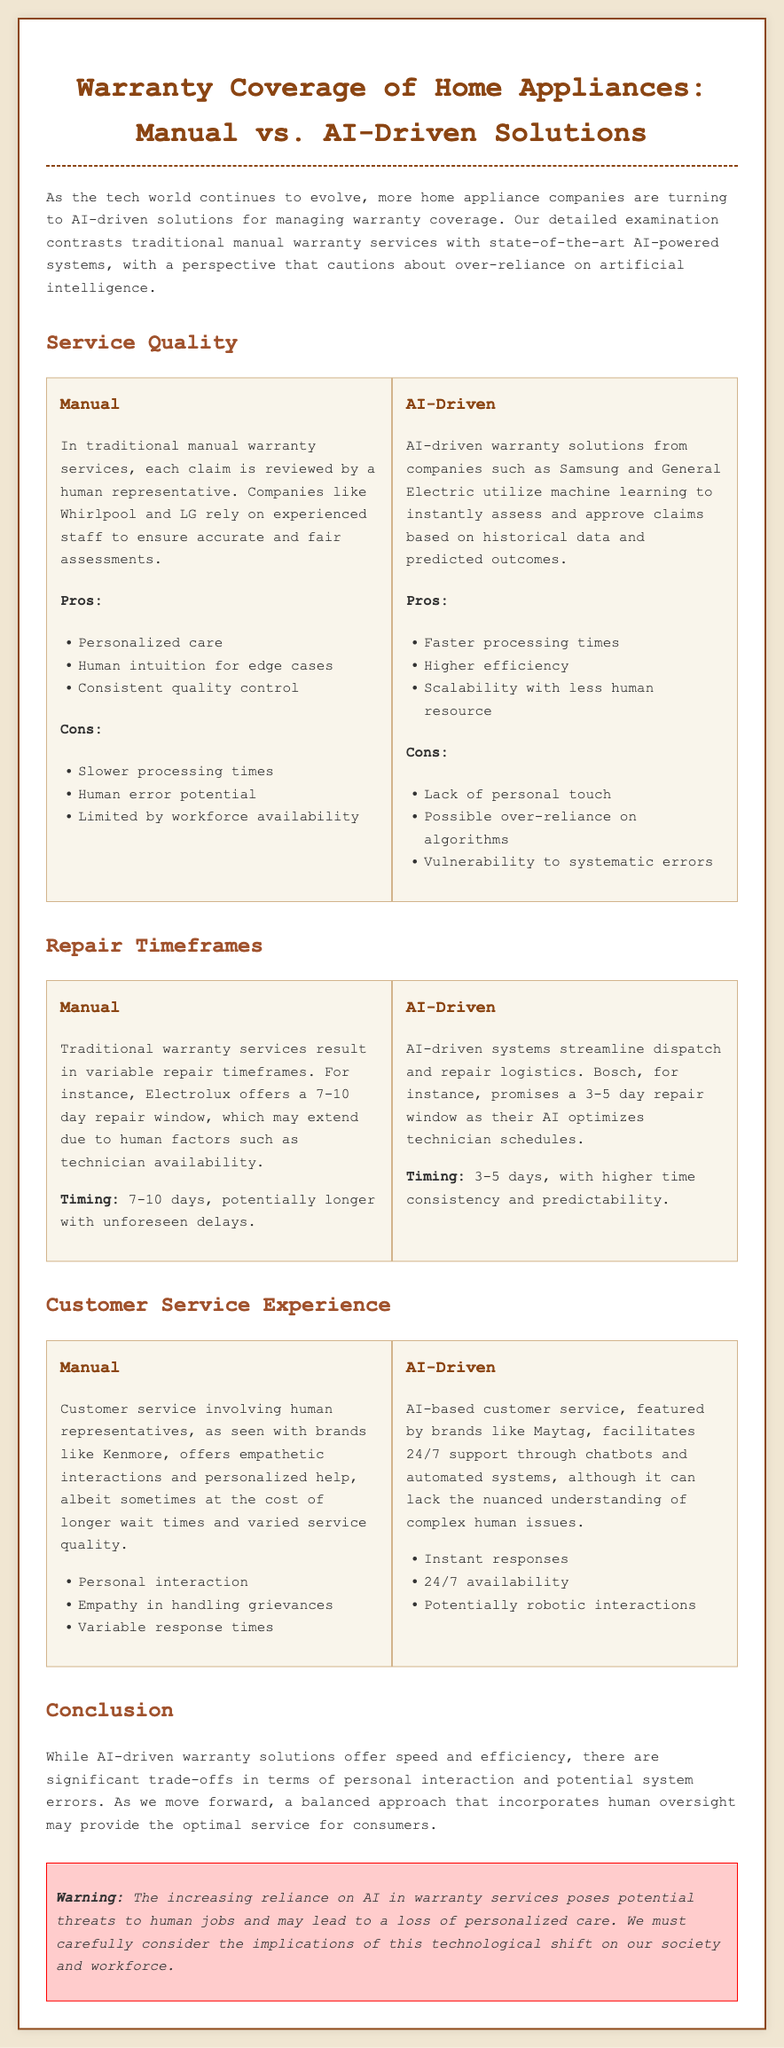What is the focus of the document? The document focuses on comparing the warranty coverage of home appliances through manual methods versus AI-driven solutions.
Answer: Comparing manual vs. AI-driven warranty coverage What is a pro of manual warranty services? The document lists several pros of manual warranty services, including personalized care.
Answer: Personalized care What repair timeframe does Bosch promise with AI-driven systems? The document states that Bosch promises a 3-5 day repair window due to optimized scheduling by AI.
Answer: 3-5 days What is a con of AI-driven warranty services? The document mentions potential over-reliance on algorithms as a con of AI-driven warranty services.
Answer: Over-reliance on algorithms Which brand is associated with empathetic customer service? The document associates empathetic customer service with human representatives from Kenmore.
Answer: Kenmore What trade-off is highlighted in the conclusion regarding AI-driven solutions? The conclusion emphasizes significant trade-offs in terms of personal interaction with reliance on AI-driven solutions.
Answer: Personal interaction What type of warranty service offers 24/7 support? The document states that AI-based customer service offers 24/7 support through automated systems.
Answer: AI-based customer service What is the warning provided at the end of the document? The document warns about potential threats to human jobs and loss of personalized care due to AI reliance.
Answer: Potential threats to human jobs What is the average repair timeframe for Electrolux's manual warranty service? The document mentions that Electrolux offers a 7-10 day repair window for its manual warranty service.
Answer: 7-10 days 